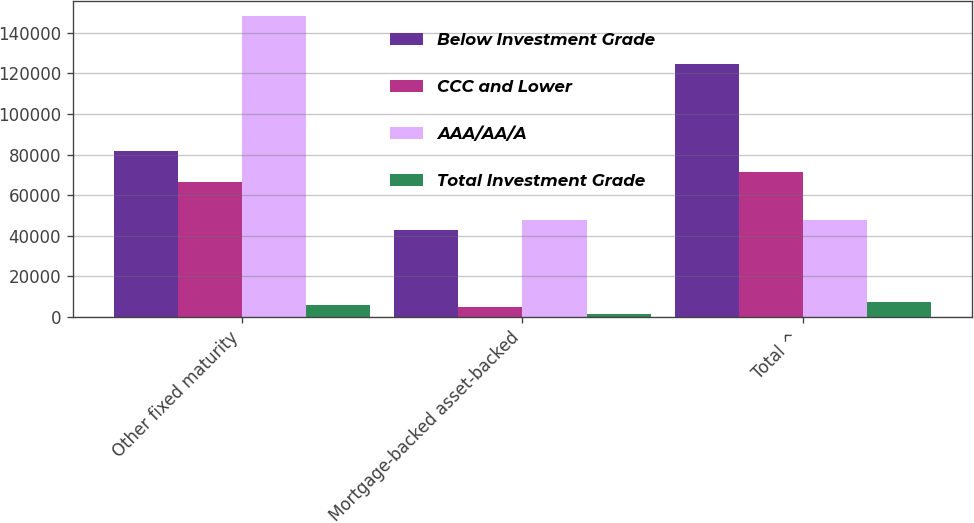<chart> <loc_0><loc_0><loc_500><loc_500><stacked_bar_chart><ecel><fcel>Other fixed maturity<fcel>Mortgage-backed asset-backed<fcel>Total ^<nl><fcel>Below Investment Grade<fcel>81571<fcel>42776<fcel>124347<nl><fcel>CCC and Lower<fcel>66364<fcel>5182<fcel>71546<nl><fcel>AAA/AA/A<fcel>147935<fcel>47958<fcel>47958<nl><fcel>Total Investment Grade<fcel>6151<fcel>1443<fcel>7594<nl></chart> 